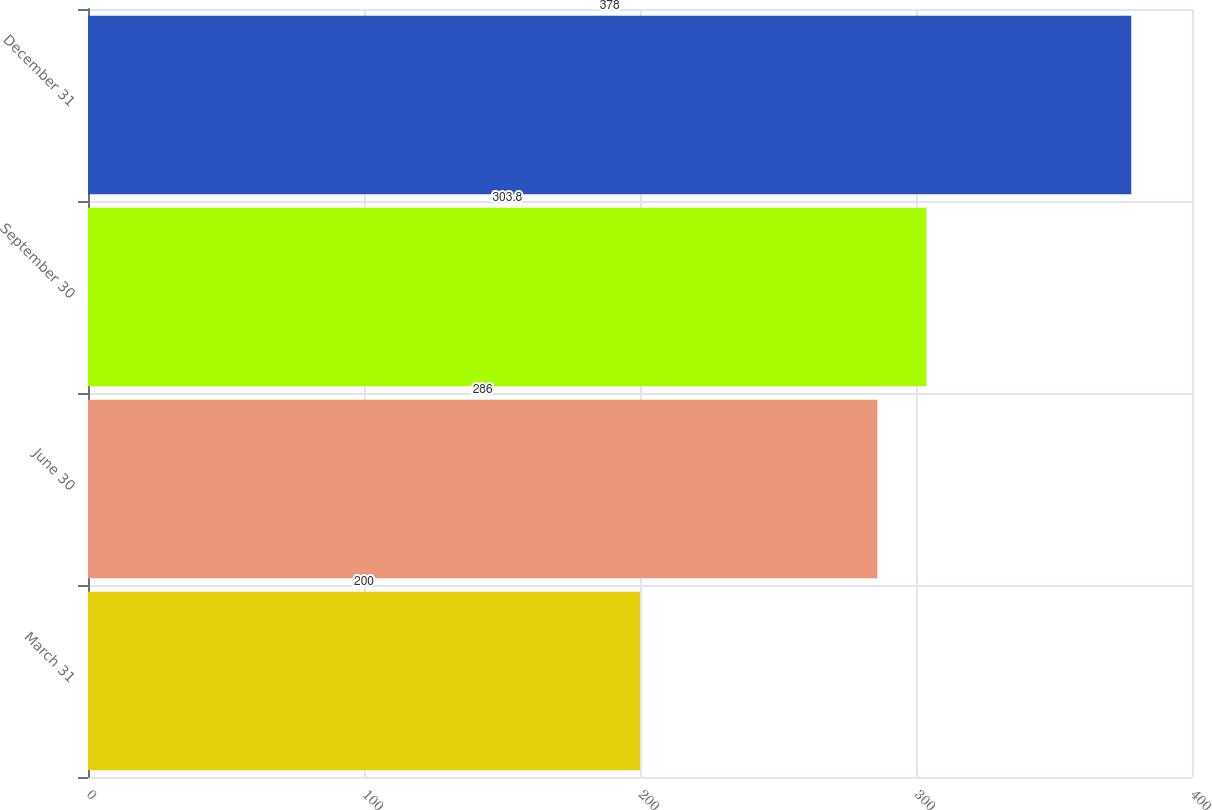<chart> <loc_0><loc_0><loc_500><loc_500><bar_chart><fcel>March 31<fcel>June 30<fcel>September 30<fcel>December 31<nl><fcel>200<fcel>286<fcel>303.8<fcel>378<nl></chart> 